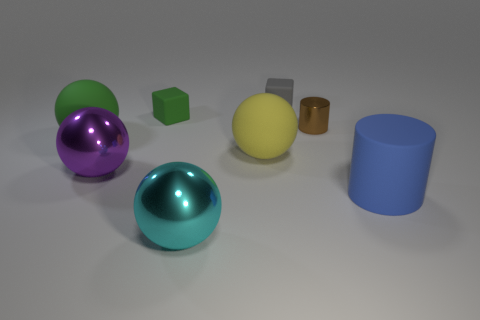Are there any other big green matte things of the same shape as the big green matte thing?
Offer a terse response. No. There is a metallic object in front of the cylinder in front of the tiny brown metal thing; what is its shape?
Make the answer very short. Sphere. What number of other small cylinders have the same material as the brown cylinder?
Your answer should be very brief. 0. The large sphere that is made of the same material as the cyan object is what color?
Offer a terse response. Purple. What size is the green thing on the right side of the green rubber sphere behind the large shiny object that is behind the big blue rubber cylinder?
Provide a short and direct response. Small. Is the number of purple matte objects less than the number of tiny green objects?
Make the answer very short. Yes. There is another object that is the same shape as the blue matte object; what is its color?
Give a very brief answer. Brown. There is a cylinder in front of the large matte ball behind the large yellow ball; is there a tiny gray thing on the right side of it?
Give a very brief answer. No. Do the gray thing and the small green rubber object have the same shape?
Your response must be concise. Yes. Is the number of blue rubber cylinders on the left side of the green matte sphere less than the number of cyan cylinders?
Your answer should be compact. No. 